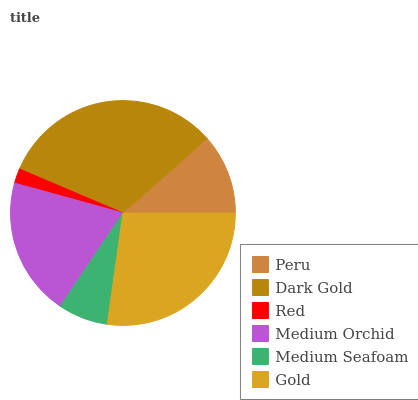Is Red the minimum?
Answer yes or no. Yes. Is Dark Gold the maximum?
Answer yes or no. Yes. Is Dark Gold the minimum?
Answer yes or no. No. Is Red the maximum?
Answer yes or no. No. Is Dark Gold greater than Red?
Answer yes or no. Yes. Is Red less than Dark Gold?
Answer yes or no. Yes. Is Red greater than Dark Gold?
Answer yes or no. No. Is Dark Gold less than Red?
Answer yes or no. No. Is Medium Orchid the high median?
Answer yes or no. Yes. Is Peru the low median?
Answer yes or no. Yes. Is Red the high median?
Answer yes or no. No. Is Gold the low median?
Answer yes or no. No. 